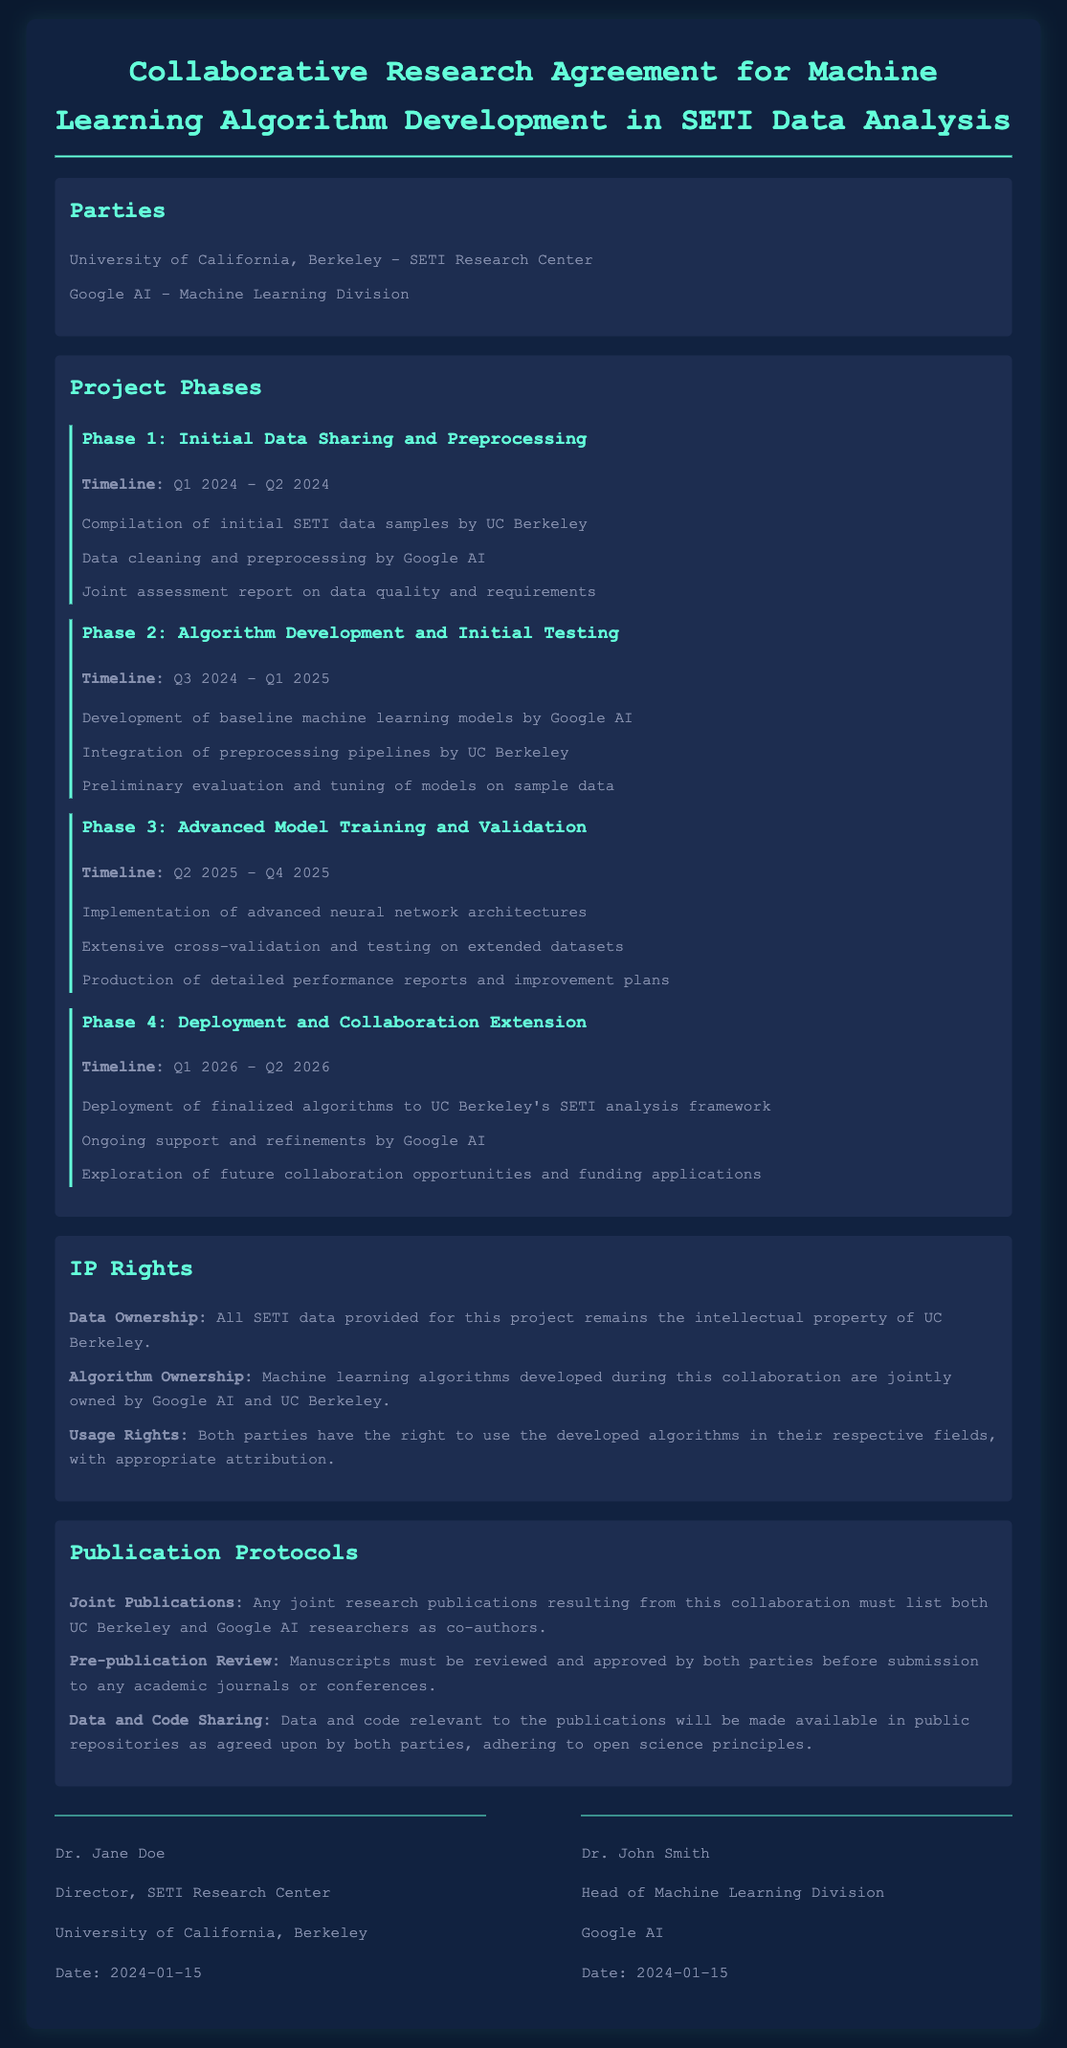What is the name of the university involved in the agreement? The university involved in the agreement is specified in the parties section.
Answer: University of California, Berkeley What is the duration of Phase 1? The timeline for Phase 1 is indicated in the project phases section.
Answer: Q1 2024 - Q2 2024 Who is responsible for data cleaning in Phase 1? The document states which party is responsible for data tasks in this phase.
Answer: Google AI What are the joint publications protocol according to the agreement? The publication protocols detail how authorship should be handled.
Answer: Co-authors What entities jointly own the developed algorithms? The section on IP Rights specifies ownership of the algorithms produced.
Answer: Google AI and UC Berkeley When was the agreement signed? The signatures section provides the date of signing the agreement.
Answer: 2024-01-15 What is the primary purpose of the collaboration? This is inferred from the title of the agreement detailing the main focus.
Answer: Machine Learning Algorithm Development What is the key focus of Phase 3? The description in Phase 3 outlines the main activities planned.
Answer: Advanced Model Training and Validation 